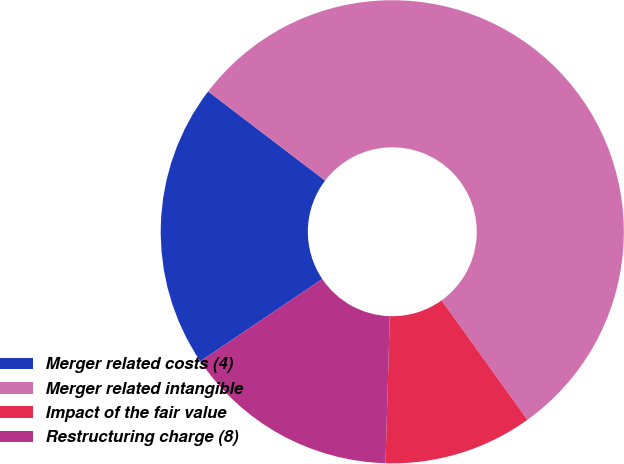Convert chart. <chart><loc_0><loc_0><loc_500><loc_500><pie_chart><fcel>Merger related costs (4)<fcel>Merger related intangible<fcel>Impact of the fair value<fcel>Restructuring charge (8)<nl><fcel>19.81%<fcel>54.72%<fcel>10.38%<fcel>15.09%<nl></chart> 